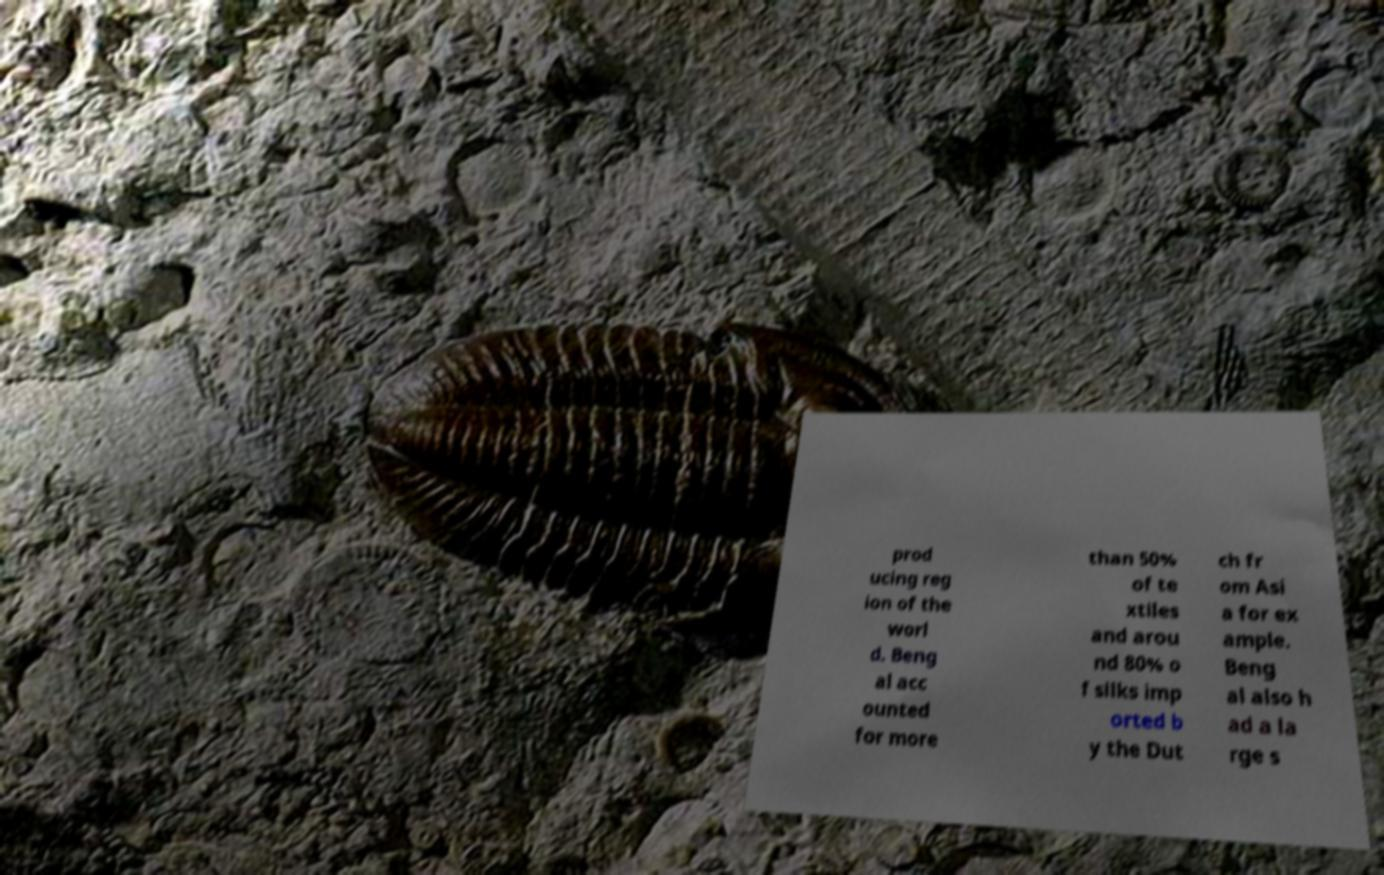Can you read and provide the text displayed in the image?This photo seems to have some interesting text. Can you extract and type it out for me? prod ucing reg ion of the worl d. Beng al acc ounted for more than 50% of te xtiles and arou nd 80% o f silks imp orted b y the Dut ch fr om Asi a for ex ample. Beng al also h ad a la rge s 